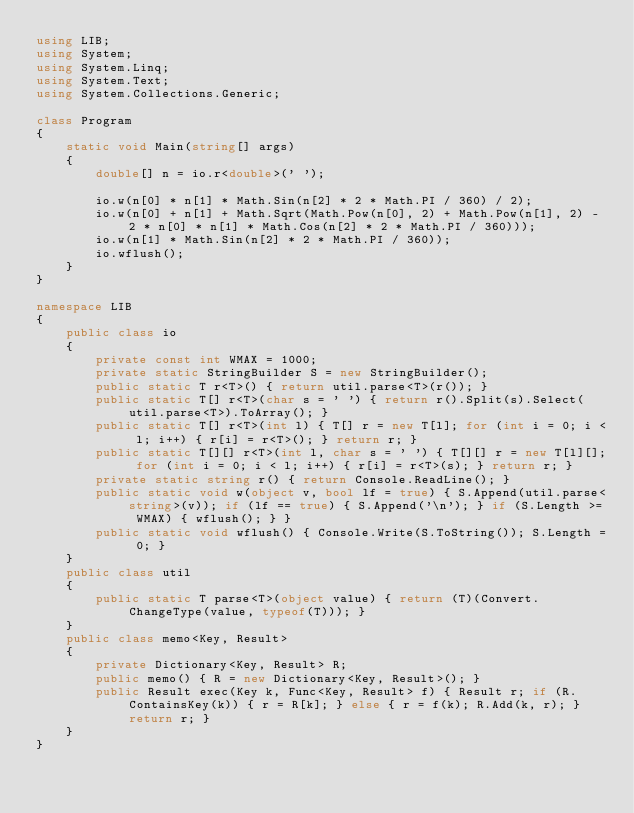Convert code to text. <code><loc_0><loc_0><loc_500><loc_500><_C#_>using LIB;
using System;
using System.Linq;
using System.Text;
using System.Collections.Generic;

class Program
{
    static void Main(string[] args)
    {
        double[] n = io.r<double>(' ');

        io.w(n[0] * n[1] * Math.Sin(n[2] * 2 * Math.PI / 360) / 2);
        io.w(n[0] + n[1] + Math.Sqrt(Math.Pow(n[0], 2) + Math.Pow(n[1], 2) - 2 * n[0] * n[1] * Math.Cos(n[2] * 2 * Math.PI / 360)));
        io.w(n[1] * Math.Sin(n[2] * 2 * Math.PI / 360));
        io.wflush();
    }
}

namespace LIB
{
    public class io
    {
        private const int WMAX = 1000;
        private static StringBuilder S = new StringBuilder();
        public static T r<T>() { return util.parse<T>(r()); }
        public static T[] r<T>(char s = ' ') { return r().Split(s).Select(util.parse<T>).ToArray(); }
        public static T[] r<T>(int l) { T[] r = new T[l]; for (int i = 0; i < l; i++) { r[i] = r<T>(); } return r; }
        public static T[][] r<T>(int l, char s = ' ') { T[][] r = new T[l][]; for (int i = 0; i < l; i++) { r[i] = r<T>(s); } return r; }
        private static string r() { return Console.ReadLine(); }
        public static void w(object v, bool lf = true) { S.Append(util.parse<string>(v)); if (lf == true) { S.Append('\n'); } if (S.Length >= WMAX) { wflush(); } }
        public static void wflush() { Console.Write(S.ToString()); S.Length = 0; }
    }
    public class util
    {
        public static T parse<T>(object value) { return (T)(Convert.ChangeType(value, typeof(T))); }
    }
    public class memo<Key, Result>
    {
        private Dictionary<Key, Result> R;
        public memo() { R = new Dictionary<Key, Result>(); }
        public Result exec(Key k, Func<Key, Result> f) { Result r; if (R.ContainsKey(k)) { r = R[k]; } else { r = f(k); R.Add(k, r); } return r; }
    }
}</code> 